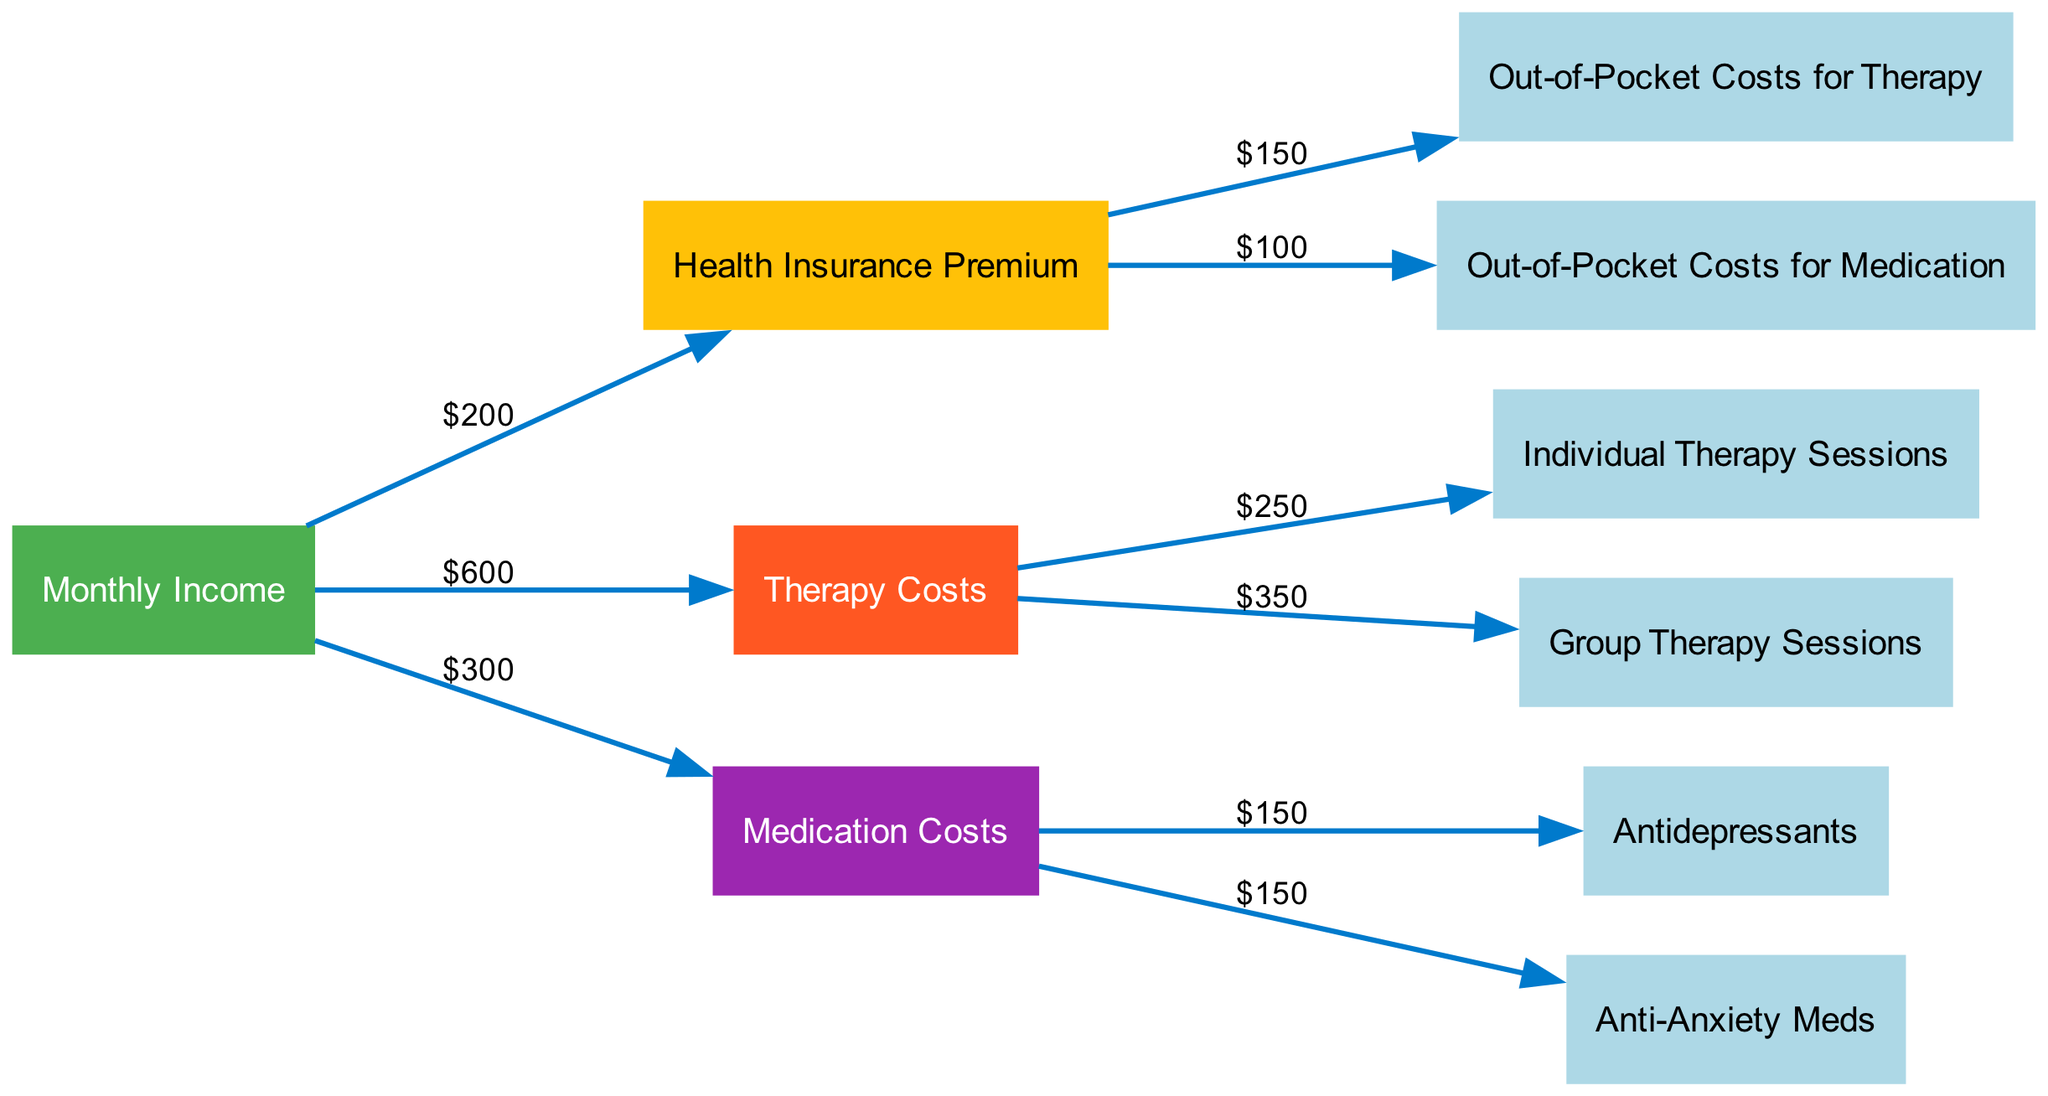What is the total amount allocated to therapy costs? The diagram shows separate flows for individual therapy sessions ($250) and group therapy sessions ($350). Adding these amounts gives $250 + $350 = $600 for total therapy costs.
Answer: 600 What are the out-of-pocket costs for anti-anxiety medications? The diagram specifies the expense of anti-anxiety meds, which is shown as $150 under medication costs.
Answer: 150 How much does the health insurance premium contribute to out-of-pocket therapy expenses? According to the diagram, the health insurance premium contributes $150 toward out-of-pocket costs for therapy.
Answer: 150 What is the total monthly income shown in the diagram? The diagram reflects multiple expenses originating from the monthly income. Adding therapy costs ($600) and medication costs ($300), we conclude the monthly income must be at least $900, since all expenses are sourced from it.
Answer: 900 Which node has the highest individual expense amount? From the therapy costs breakdown, the group therapy sessions show an expense of $350, which is the highest single expense in this diagram.
Answer: Group Therapy Sessions What percentage of the total monthly income is spent on antidepressants? The antidepressants cost $150, and the total monthly income is $900. To find the percentage, calculate ($150 / $900) * 100, which equals approximately 16.67%.
Answer: 16.67% How many total expenditure nodes are there in the diagram? Counting the nodes, we see Health Insurance Premium, Out-of-Pocket Costs for Therapy, Out-of-Pocket Costs for Medication, Therapy Costs, Medication Costs, Individual Therapy Sessions, Group Therapy Sessions, Antidepressants, and Anti-Anxiety Meds. This totals to 9 nodes.
Answer: 9 What is the flow value from Medication Costs to Anti-Anxiety Meds? The diagram explicitly states that the flow value from Medication Costs to Anti-Anxiety Meds is $150.
Answer: 150 What is the combined total of health-related expenses coming from the health insurance premium? The diagram indicates that $150 goes to out-of-pocket therapy costs and $100 to out-of-pocket medication costs from the health insurance premium, leading to a combined total of $150 + $100 = $250.
Answer: 250 